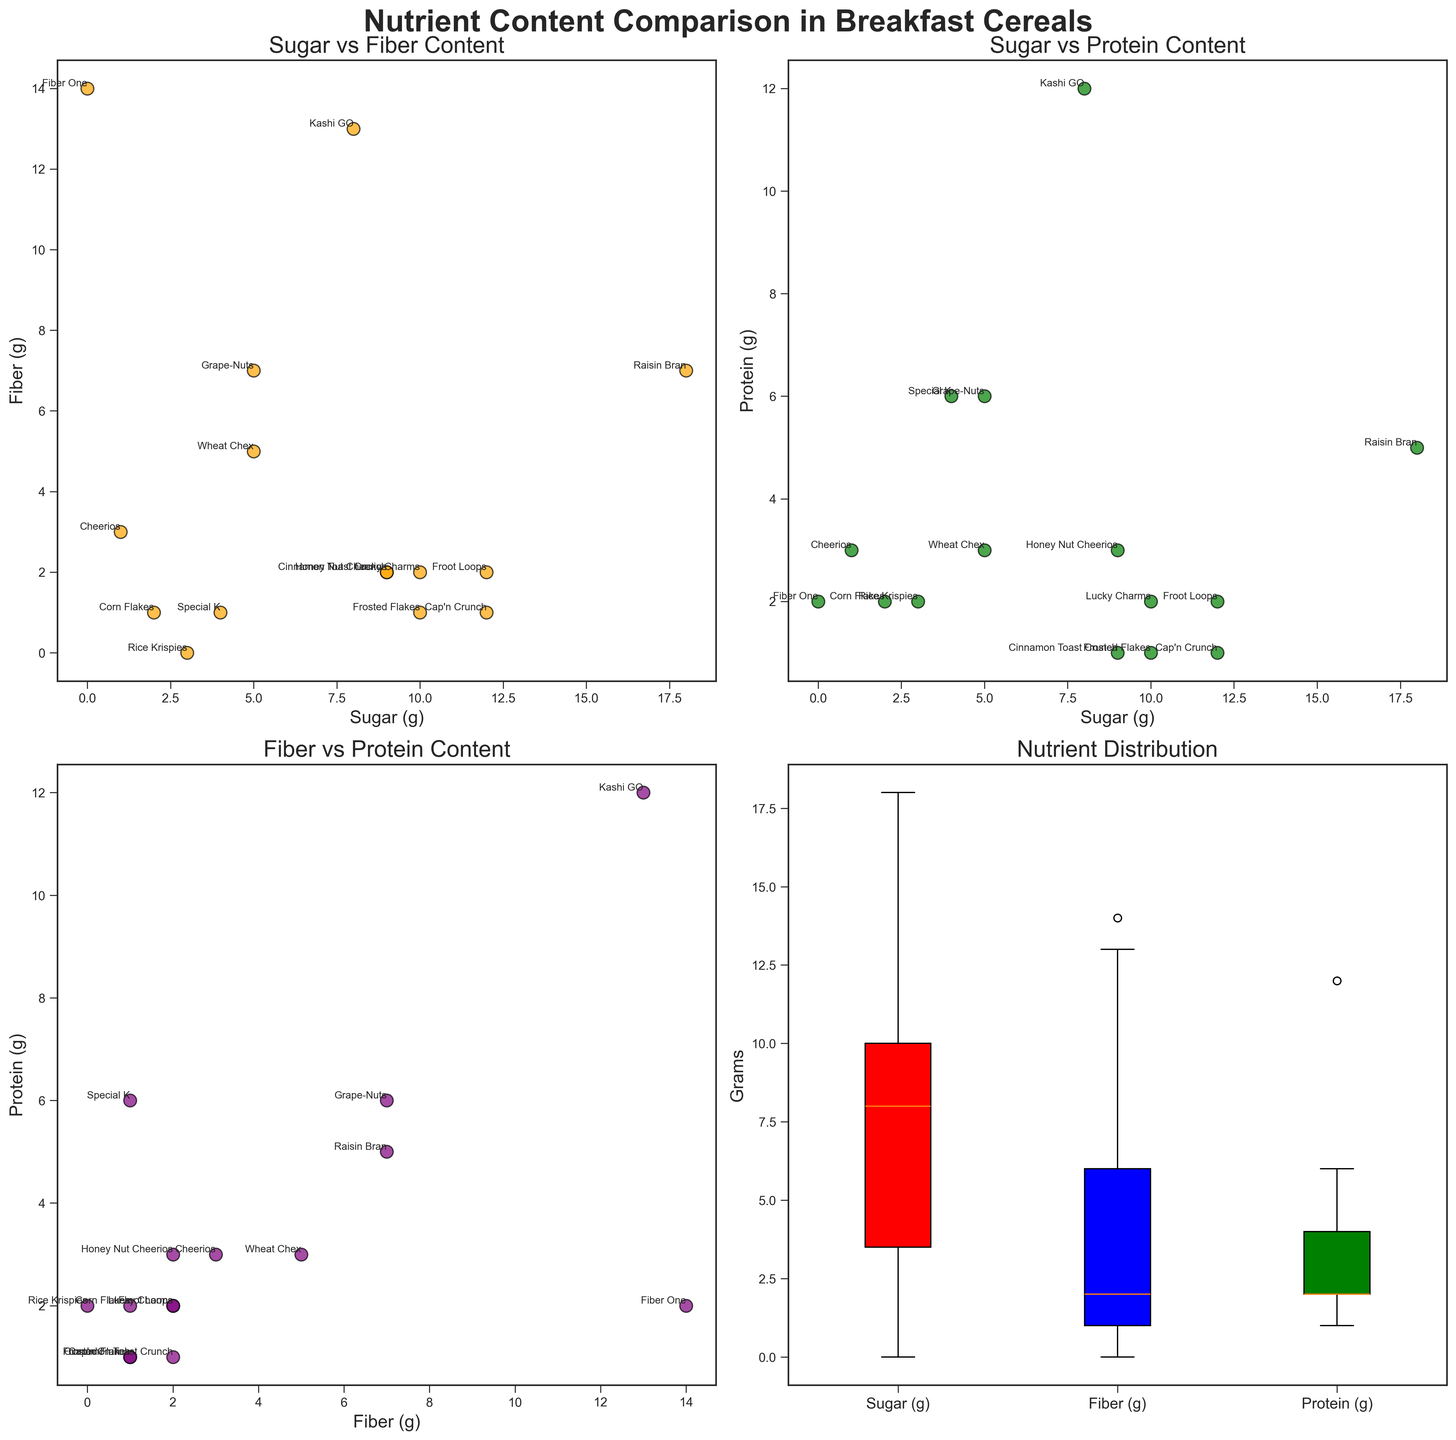What is the main title of the figure? The main title can be seen at the top of the figure.
Answer: Nutrient Content Comparison in Breakfast Cereals Which cereal has the highest sugar content? In the scatter plots, "Raisin Bran" is shown at the highest point on the Sugar (g) axis.
Answer: Raisin Bran How many data points are there in the scatter plot for "Sugar vs. Protein Content"? Each cereal represents one data point. There are 15 cereals listed.
Answer: 15 Which cereal has the highest protein content? In the "Sugar vs. Protein Content" scatter plot, "Kashi GO" is plotted at the highest point on the Protein (g) axis.
Answer: Kashi GO Which nutrient has the widest distribution according to the box plot? By comparing the range in the box plots for Sugar, Fiber, and Protein, Fiber spans the widest range from 0 to 14 grams.
Answer: Fiber Compare the sugar content of "Frosted Flakes" and "Cap'n Crunch". Which cereal has more sugar? In the "Sugar vs. Fiber Content" scatter plot, "Frosted Flakes" and "Cap'n Crunch" can be identified, and "Cap'n Crunch" has higher sugar content.
Answer: Cap'n Crunch What is the fiber level of "Honey Nut Cheerios"? Locate "Honey Nut Cheerios" in the "Sugar vs. Fiber Content" scatter plot and look at its Fiber (g) value.
Answer: 2 grams What is the median protein content based on the box plot? In the nutrient distribution box plot, identify the central line within the box for Protein. The median value is slightly above 2 grams.
Answer: Approximately 2 grams Which cereal has both high fiber and high protein content? In the "Fiber vs. Protein Content" scatter plot, "Kashi GO" stands out with high values for both nutrients.
Answer: Kashi GO Which cereal has the lowest sugar content, and how much sugar does it contain? "Fiber One" appears in the scatter plots at the 0-g sugar mark.
Answer: Fiber One, 0 grams 